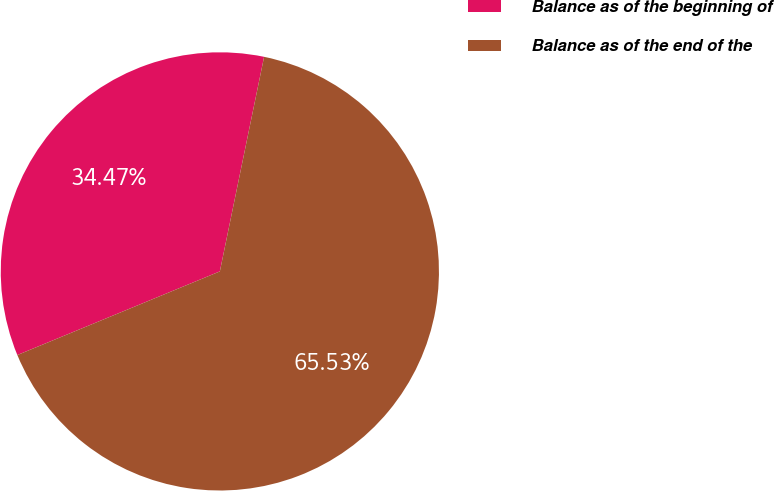Convert chart. <chart><loc_0><loc_0><loc_500><loc_500><pie_chart><fcel>Balance as of the beginning of<fcel>Balance as of the end of the<nl><fcel>34.47%<fcel>65.53%<nl></chart> 